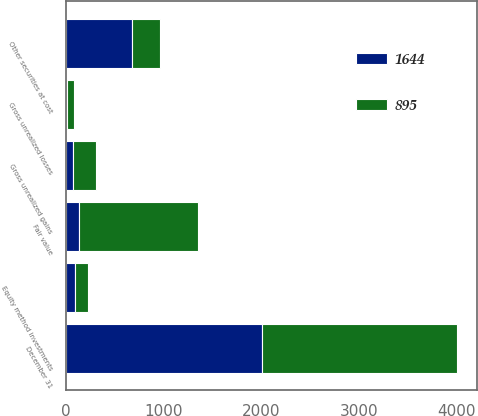<chart> <loc_0><loc_0><loc_500><loc_500><stacked_bar_chart><ecel><fcel>December 31<fcel>Gross unrealized gains<fcel>Gross unrealized losses<fcel>Fair value<fcel>Other securities at cost<fcel>Equity method investments<nl><fcel>1644<fcel>2006<fcel>68<fcel>8<fcel>130<fcel>676<fcel>89<nl><fcel>895<fcel>2005<fcel>232<fcel>75<fcel>1222<fcel>284<fcel>138<nl></chart> 